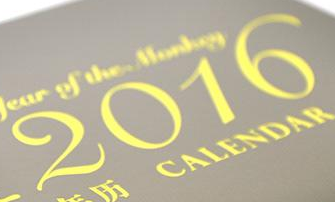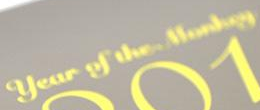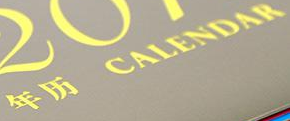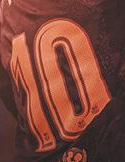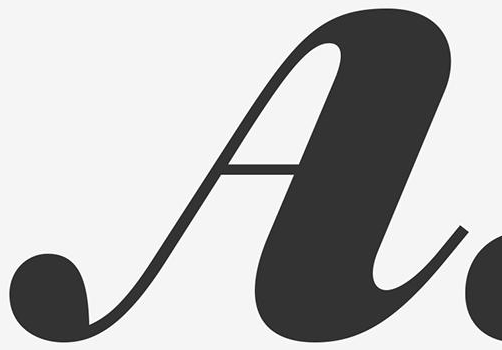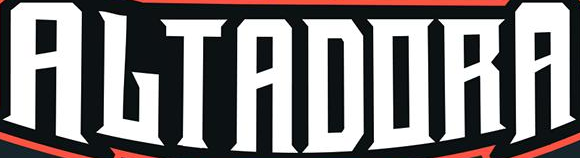Read the text content from these images in order, separated by a semicolon. 2016; #; #; 10; A; ALTADORA 